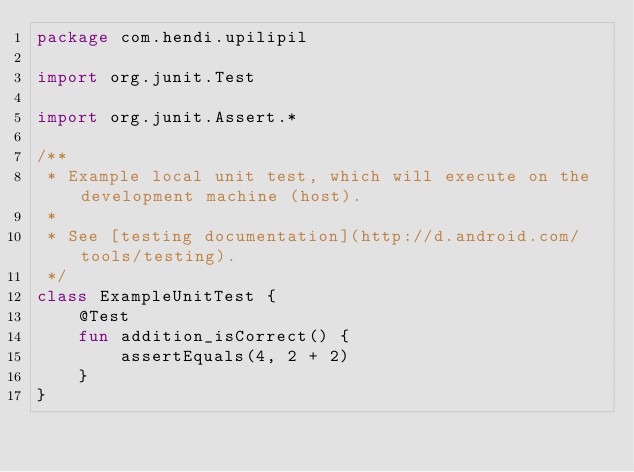Convert code to text. <code><loc_0><loc_0><loc_500><loc_500><_Kotlin_>package com.hendi.upilipil

import org.junit.Test

import org.junit.Assert.*

/**
 * Example local unit test, which will execute on the development machine (host).
 *
 * See [testing documentation](http://d.android.com/tools/testing).
 */
class ExampleUnitTest {
    @Test
    fun addition_isCorrect() {
        assertEquals(4, 2 + 2)
    }
}</code> 